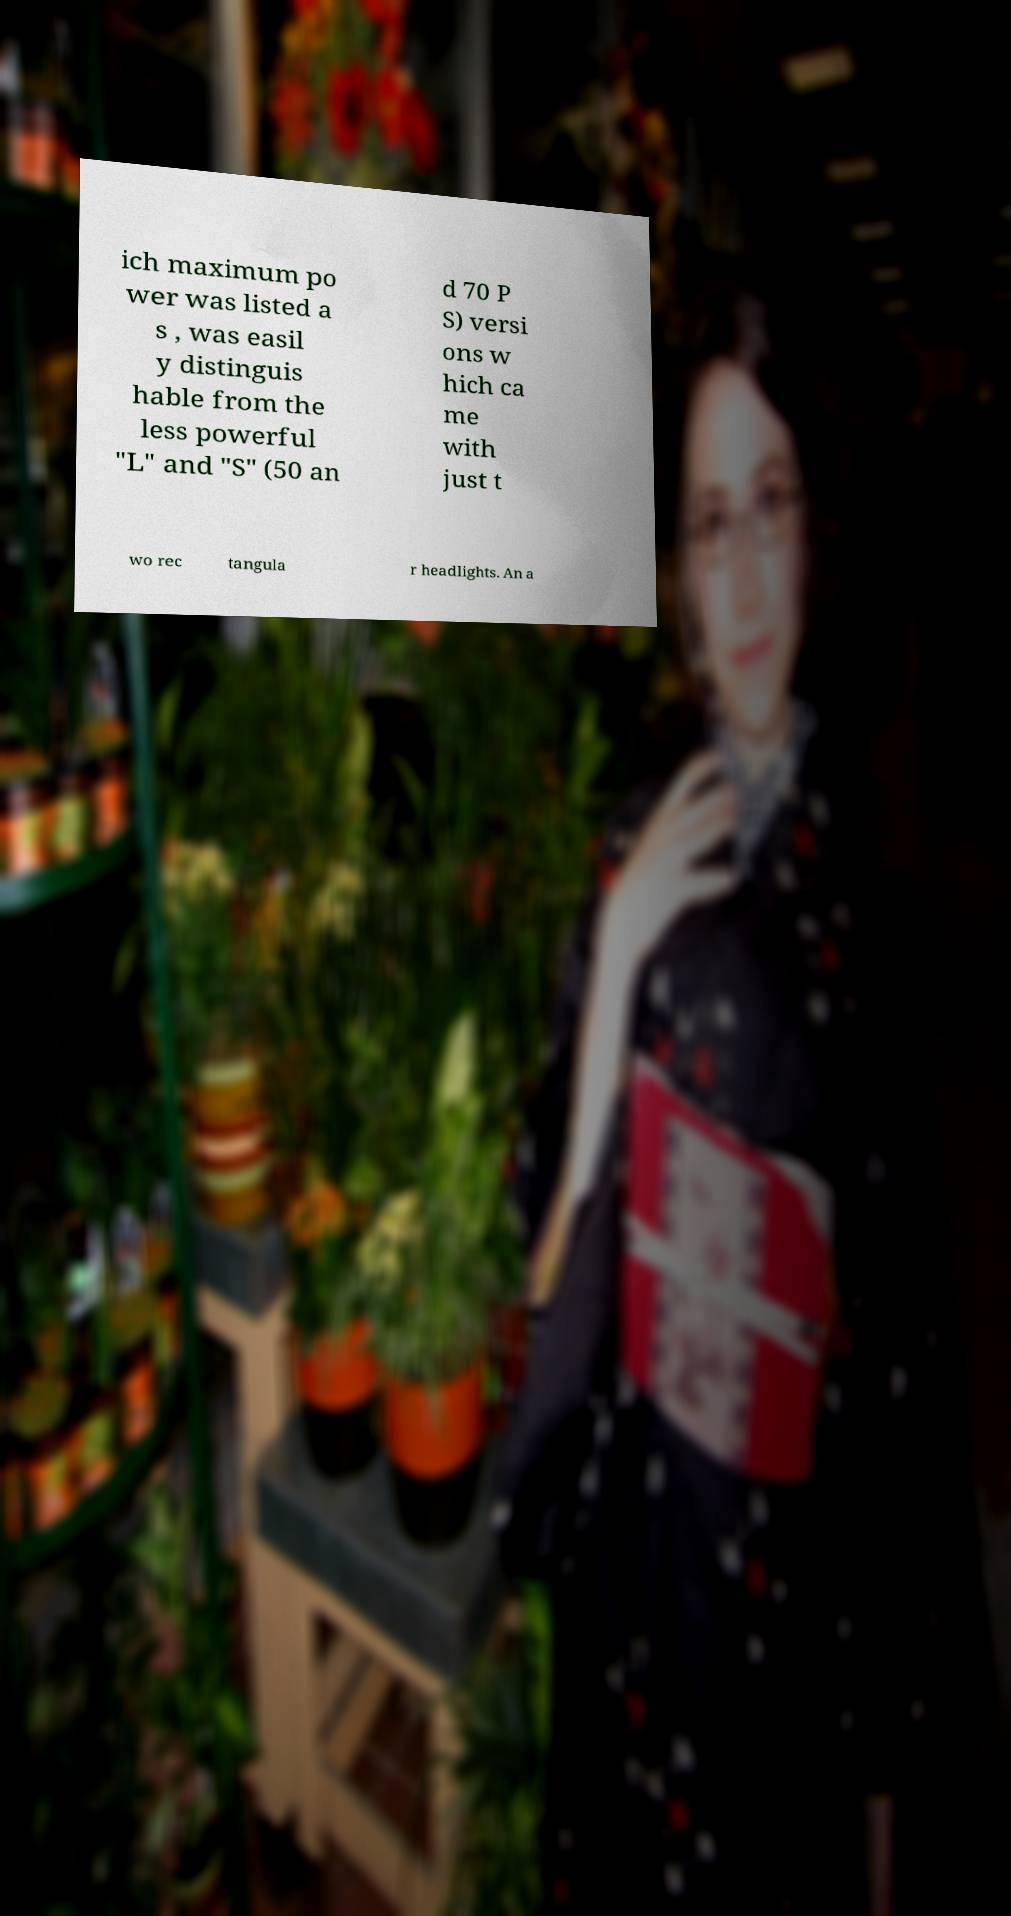Could you extract and type out the text from this image? ich maximum po wer was listed a s , was easil y distinguis hable from the less powerful "L" and "S" (50 an d 70 P S) versi ons w hich ca me with just t wo rec tangula r headlights. An a 